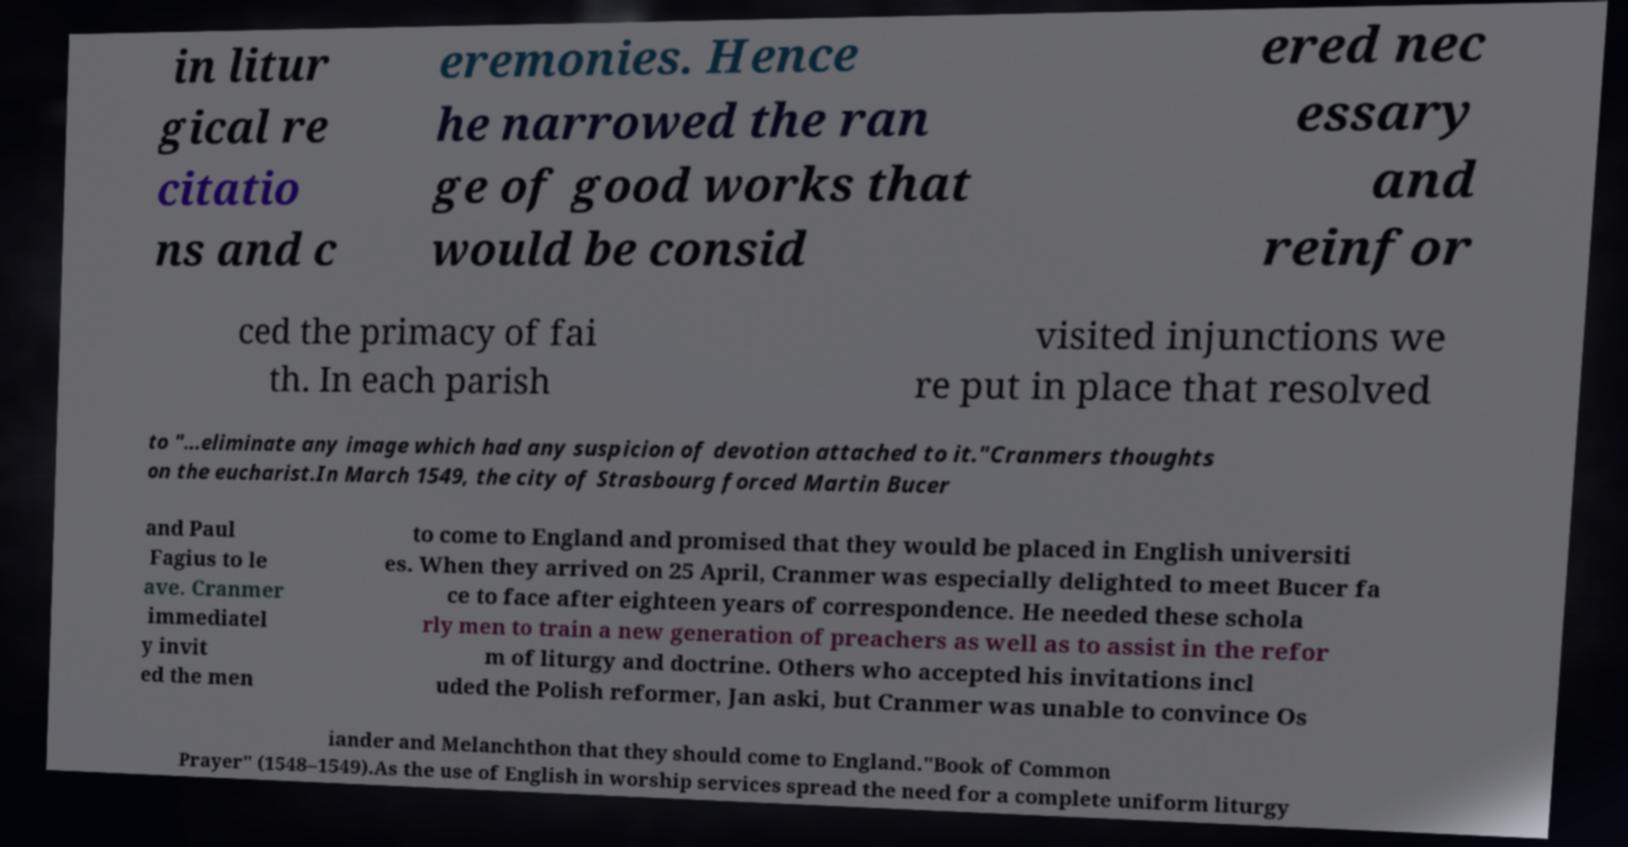What messages or text are displayed in this image? I need them in a readable, typed format. in litur gical re citatio ns and c eremonies. Hence he narrowed the ran ge of good works that would be consid ered nec essary and reinfor ced the primacy of fai th. In each parish visited injunctions we re put in place that resolved to "...eliminate any image which had any suspicion of devotion attached to it."Cranmers thoughts on the eucharist.In March 1549, the city of Strasbourg forced Martin Bucer and Paul Fagius to le ave. Cranmer immediatel y invit ed the men to come to England and promised that they would be placed in English universiti es. When they arrived on 25 April, Cranmer was especially delighted to meet Bucer fa ce to face after eighteen years of correspondence. He needed these schola rly men to train a new generation of preachers as well as to assist in the refor m of liturgy and doctrine. Others who accepted his invitations incl uded the Polish reformer, Jan aski, but Cranmer was unable to convince Os iander and Melanchthon that they should come to England."Book of Common Prayer" (1548–1549).As the use of English in worship services spread the need for a complete uniform liturgy 